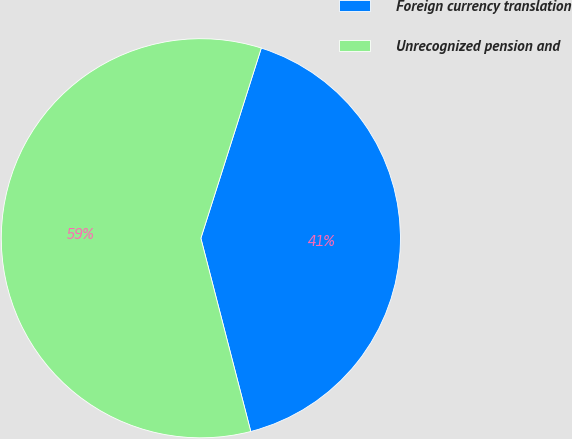Convert chart to OTSL. <chart><loc_0><loc_0><loc_500><loc_500><pie_chart><fcel>Foreign currency translation<fcel>Unrecognized pension and<nl><fcel>41.08%<fcel>58.92%<nl></chart> 